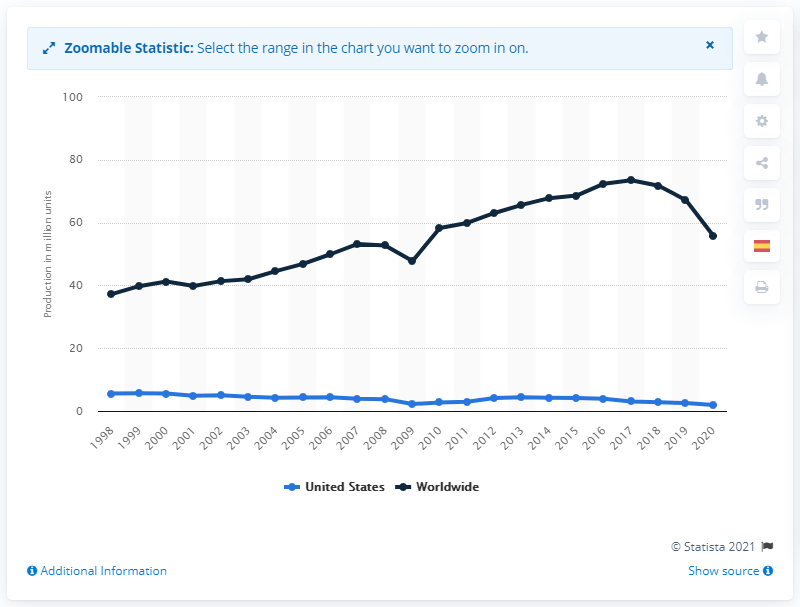Mention a couple of crucial points in this snapshot. In 2020, the global production of passenger cars was estimated to be 55.83 million units. 